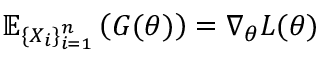<formula> <loc_0><loc_0><loc_500><loc_500>\mathbb { E } _ { \{ X _ { i } \} _ { i = 1 } ^ { n } } \left ( G ( \theta ) \right ) = \nabla _ { \theta } L ( \theta )</formula> 